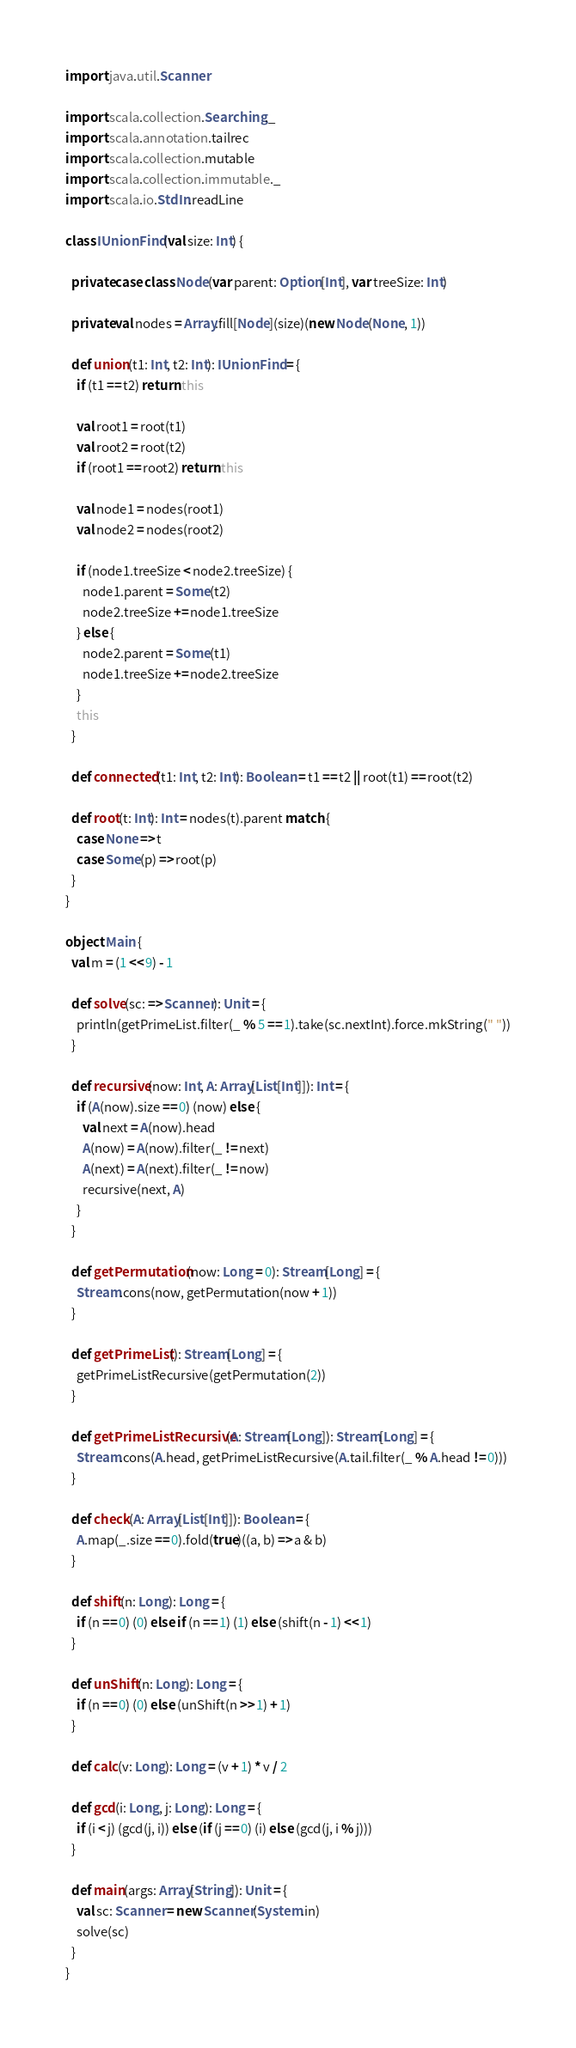Convert code to text. <code><loc_0><loc_0><loc_500><loc_500><_Scala_>import java.util.Scanner

import scala.collection.Searching._
import scala.annotation.tailrec
import scala.collection.mutable
import scala.collection.immutable._
import scala.io.StdIn.readLine

class IUnionFind(val size: Int) {

  private case class Node(var parent: Option[Int], var treeSize: Int)

  private val nodes = Array.fill[Node](size)(new Node(None, 1))

  def union(t1: Int, t2: Int): IUnionFind = {
    if (t1 == t2) return this

    val root1 = root(t1)
    val root2 = root(t2)
    if (root1 == root2) return this

    val node1 = nodes(root1)
    val node2 = nodes(root2)

    if (node1.treeSize < node2.treeSize) {
      node1.parent = Some(t2)
      node2.treeSize += node1.treeSize
    } else {
      node2.parent = Some(t1)
      node1.treeSize += node2.treeSize
    }
    this
  }

  def connected(t1: Int, t2: Int): Boolean = t1 == t2 || root(t1) == root(t2)

  def root(t: Int): Int = nodes(t).parent match {
    case None => t
    case Some(p) => root(p)
  }
}

object Main {
  val m = (1 << 9) - 1

  def solve(sc: => Scanner): Unit = {
    println(getPrimeList.filter(_ % 5 == 1).take(sc.nextInt).force.mkString(" "))
  }

  def recursive(now: Int, A: Array[List[Int]]): Int = {
    if (A(now).size == 0) (now) else {
      val next = A(now).head
      A(now) = A(now).filter(_ != next)
      A(next) = A(next).filter(_ != now)
      recursive(next, A)
    }
  }

  def getPermutation(now: Long = 0): Stream[Long] = {
    Stream.cons(now, getPermutation(now + 1))
  }

  def getPrimeList(): Stream[Long] = {
    getPrimeListRecursive(getPermutation(2))
  }

  def getPrimeListRecursive(A: Stream[Long]): Stream[Long] = {
    Stream.cons(A.head, getPrimeListRecursive(A.tail.filter(_ % A.head != 0)))
  }

  def check(A: Array[List[Int]]): Boolean = {
    A.map(_.size == 0).fold(true)((a, b) => a & b)
  }

  def shift(n: Long): Long = {
    if (n == 0) (0) else if (n == 1) (1) else (shift(n - 1) << 1)
  }

  def unShift(n: Long): Long = {
    if (n == 0) (0) else (unShift(n >> 1) + 1)
  }

  def calc(v: Long): Long = (v + 1) * v / 2

  def gcd(i: Long, j: Long): Long = {
    if (i < j) (gcd(j, i)) else (if (j == 0) (i) else (gcd(j, i % j)))
  }

  def main(args: Array[String]): Unit = {
    val sc: Scanner = new Scanner(System.in)
    solve(sc)
  }
}</code> 